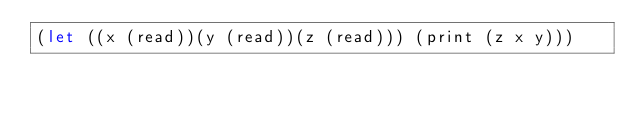<code> <loc_0><loc_0><loc_500><loc_500><_Scheme_>(let ((x (read))(y (read))(z (read))) (print (z x y)))</code> 